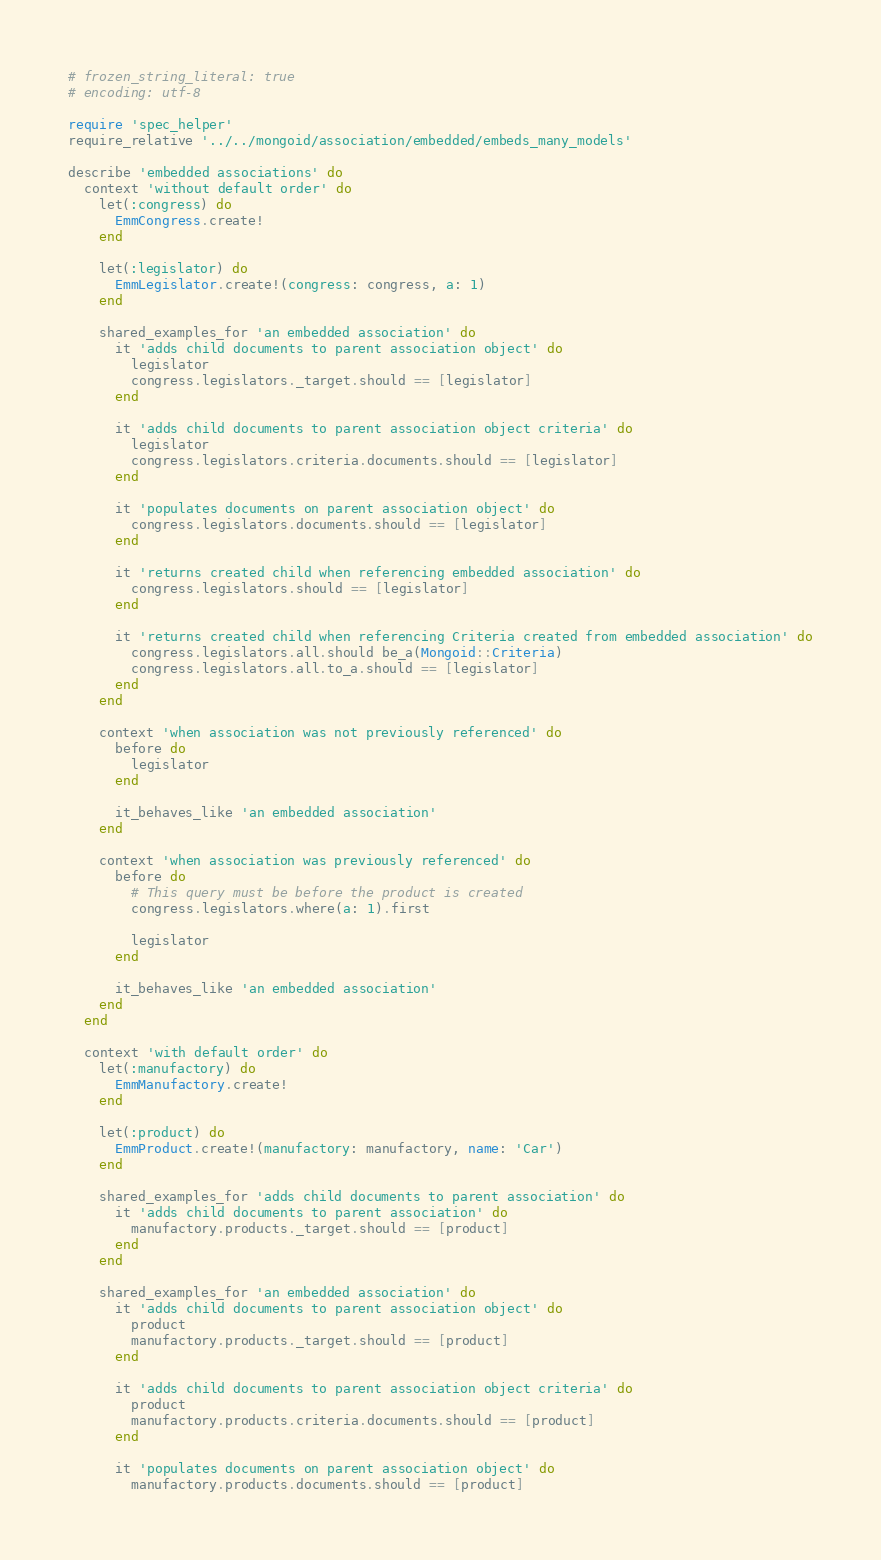<code> <loc_0><loc_0><loc_500><loc_500><_Ruby_># frozen_string_literal: true
# encoding: utf-8

require 'spec_helper'
require_relative '../../mongoid/association/embedded/embeds_many_models'

describe 'embedded associations' do
  context 'without default order' do
    let(:congress) do
      EmmCongress.create!
    end

    let(:legislator) do
      EmmLegislator.create!(congress: congress, a: 1)
    end

    shared_examples_for 'an embedded association' do
      it 'adds child documents to parent association object' do
        legislator
        congress.legislators._target.should == [legislator]
      end

      it 'adds child documents to parent association object criteria' do
        legislator
        congress.legislators.criteria.documents.should == [legislator]
      end

      it 'populates documents on parent association object' do
        congress.legislators.documents.should == [legislator]
      end

      it 'returns created child when referencing embedded association' do
        congress.legislators.should == [legislator]
      end

      it 'returns created child when referencing Criteria created from embedded association' do
        congress.legislators.all.should be_a(Mongoid::Criteria)
        congress.legislators.all.to_a.should == [legislator]
      end
    end

    context 'when association was not previously referenced' do
      before do
        legislator
      end

      it_behaves_like 'an embedded association'
    end

    context 'when association was previously referenced' do
      before do
        # This query must be before the product is created
        congress.legislators.where(a: 1).first

        legislator
      end

      it_behaves_like 'an embedded association'
    end
  end

  context 'with default order' do
    let(:manufactory) do
      EmmManufactory.create!
    end

    let(:product) do
      EmmProduct.create!(manufactory: manufactory, name: 'Car')
    end

    shared_examples_for 'adds child documents to parent association' do
      it 'adds child documents to parent association' do
        manufactory.products._target.should == [product]
      end
    end

    shared_examples_for 'an embedded association' do
      it 'adds child documents to parent association object' do
        product
        manufactory.products._target.should == [product]
      end

      it 'adds child documents to parent association object criteria' do
        product
        manufactory.products.criteria.documents.should == [product]
      end

      it 'populates documents on parent association object' do
        manufactory.products.documents.should == [product]</code> 